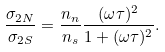Convert formula to latex. <formula><loc_0><loc_0><loc_500><loc_500>\frac { \sigma _ { 2 N } } { \sigma _ { 2 S } } = \frac { n _ { n } } { n _ { s } } \frac { ( \omega \tau ) ^ { 2 } } { 1 + ( \omega \tau ) ^ { 2 } } .</formula> 